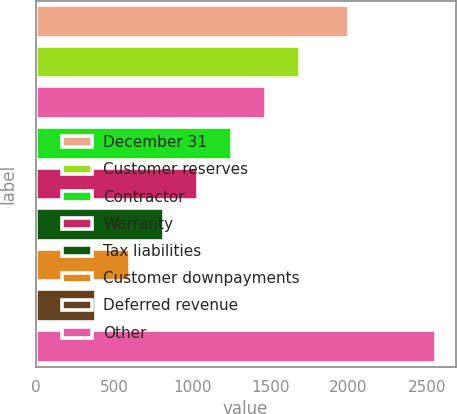<chart> <loc_0><loc_0><loc_500><loc_500><bar_chart><fcel>December 31<fcel>Customer reserves<fcel>Unnamed: 2<fcel>Contractor<fcel>Warranty<fcel>Tax liabilities<fcel>Customer downpayments<fcel>Deferred revenue<fcel>Other<nl><fcel>2005<fcel>1688.4<fcel>1471.5<fcel>1254.6<fcel>1037.7<fcel>820.8<fcel>603.9<fcel>387<fcel>2556<nl></chart> 